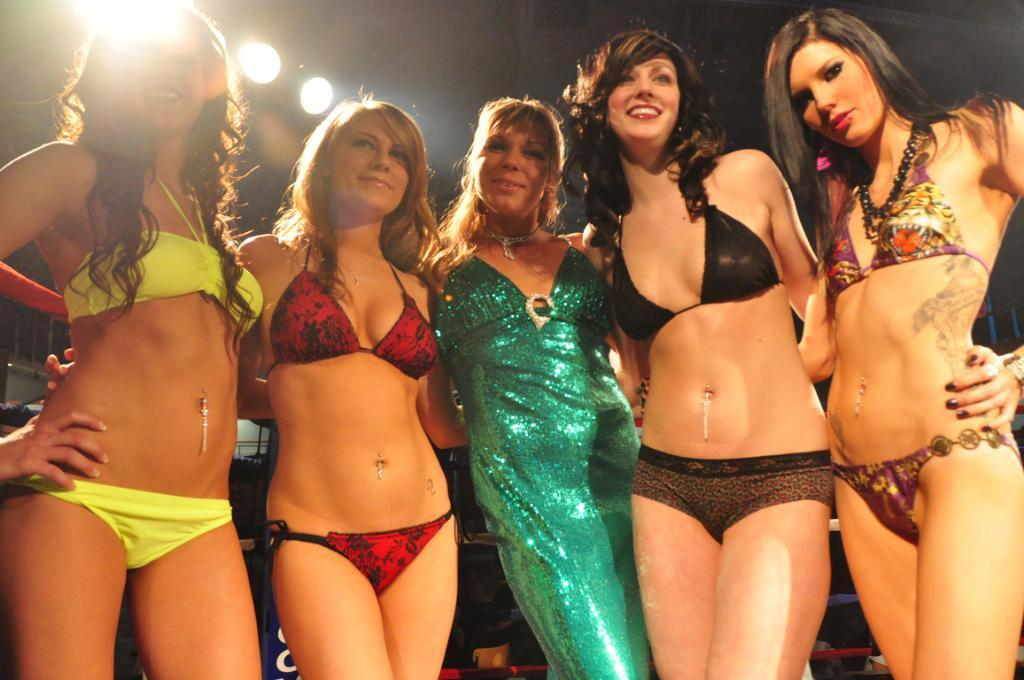Who is present in the image? There are girls in the image. What are the girls doing in the image? The girls are standing and smiling. What can be observed about the background of the image? The background of the image is dark. What type of payment is being made by the horse in the image? There is no horse present in the image, and therefore no payment can be made. 